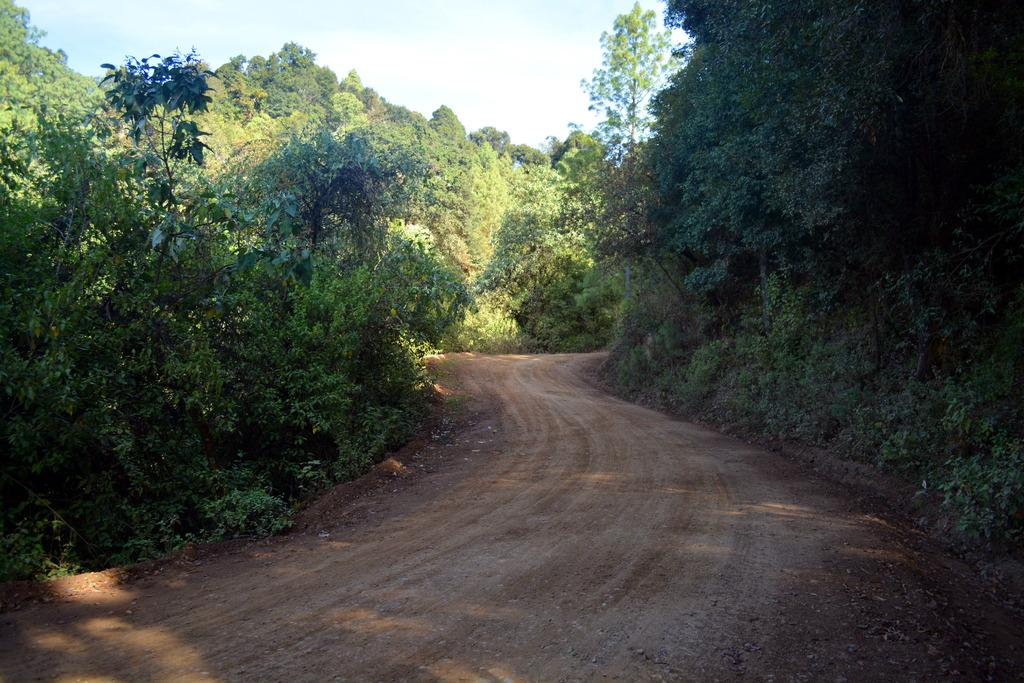What type of vegetation can be seen in the image? There are trees in the image. What can be seen on the ground in the image? There is a path visible in the image. What is visible in the background of the image? The sky is visible in the image. What word is written on the plate held by the girl in the image? There is no girl or plate present in the image, so no word can be read from a plate. 